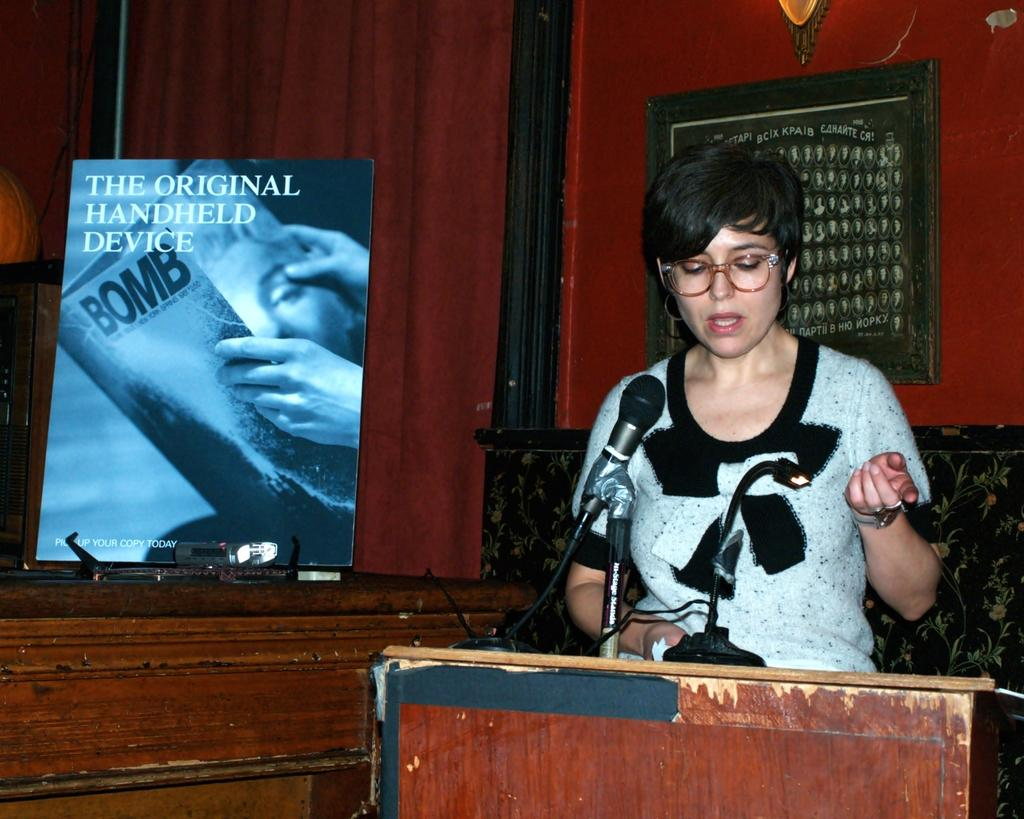Who is the main subject in the foreground of the image? There is a woman in the foreground of the image. What is the woman standing in front of? The woman is standing in front of a table. What object can be seen on the table? A microphone (mike) is present on the table. What can be seen in the background of the image? There is a wall and a board in the background of the image. What type of location might the image be taken in? The image is likely taken in a hall. What type of church can be seen in the background of the image? There is no church present in the background of the image; it features a wall and a board. What type of border is visible between the woman and the table? There is no border visible between the woman and the table; they are simply in close proximity to each other. 